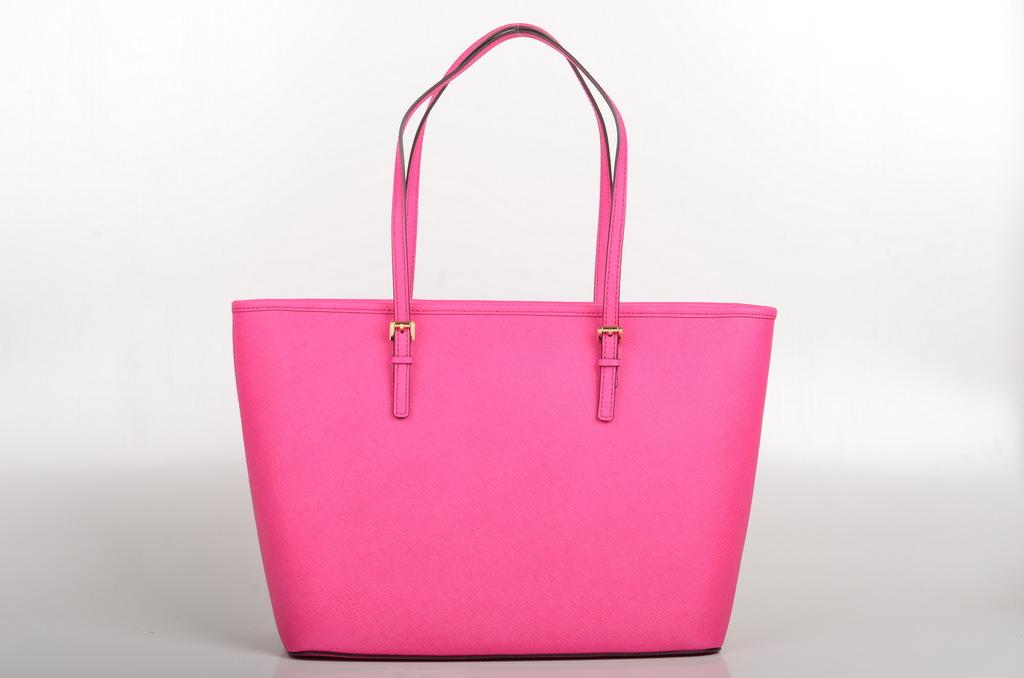What color is the bag that is visible in the image? There is a pink color bag in the image. How many clovers are growing out of the bag in the image? There are no clovers present in the image, as it only features a pink color bag. 